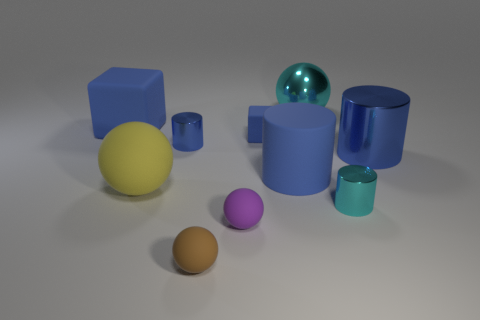Subtract all blue cylinders. How many were subtracted if there are1blue cylinders left? 2 Subtract all yellow spheres. How many blue cylinders are left? 3 Subtract 1 balls. How many balls are left? 3 Subtract all blue cylinders. Subtract all blue blocks. How many cylinders are left? 1 Subtract all spheres. How many objects are left? 6 Subtract all matte objects. Subtract all tiny brown matte objects. How many objects are left? 3 Add 7 tiny blue rubber objects. How many tiny blue rubber objects are left? 8 Add 4 purple objects. How many purple objects exist? 5 Subtract 0 brown cubes. How many objects are left? 10 